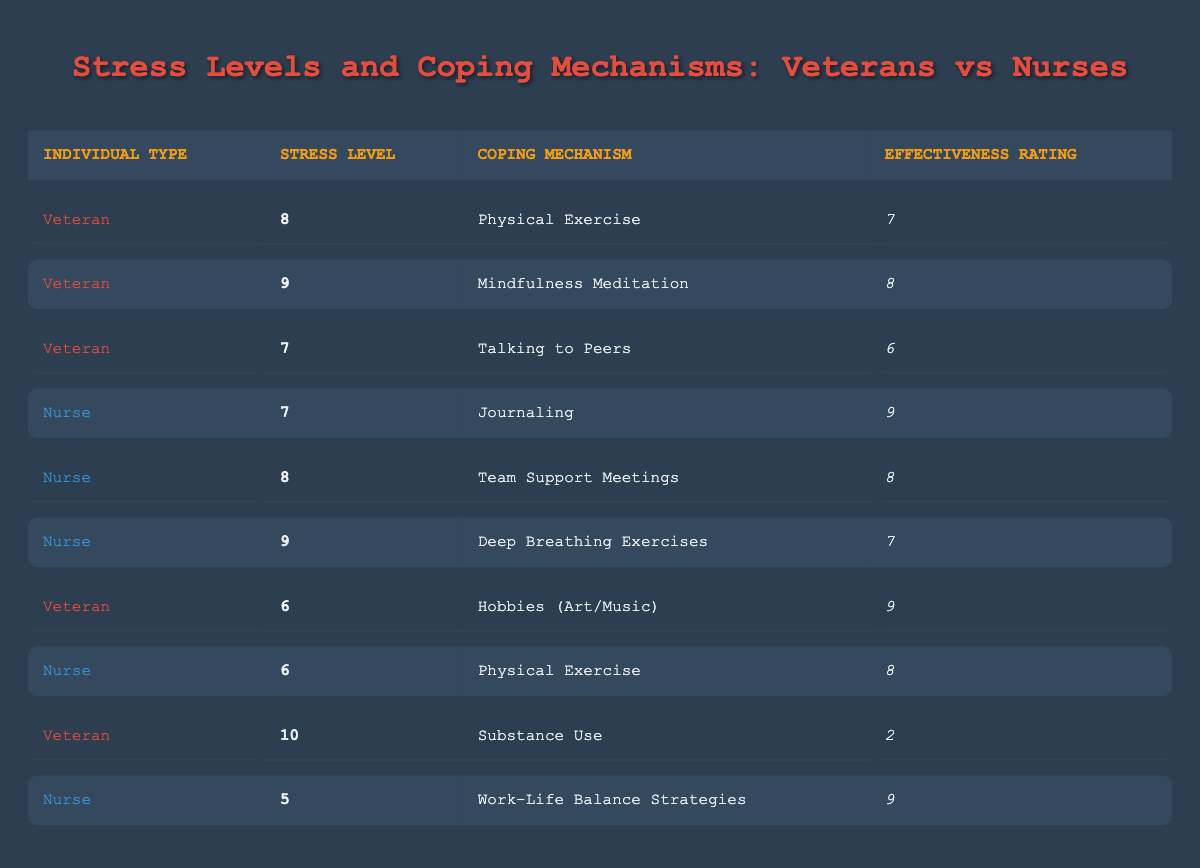What is the stress level of the veteran using "Mindfulness Meditation"? The table shows that the stress level of the veteran using "Mindfulness Meditation" is listed in the second row, where it specifically states the stress level is 9.
Answer: 9 What coping mechanism has the highest effectiveness rating among nurses? The table indicates that "Journaling" has an effectiveness rating of 9, which is the highest among all the coping mechanisms listed under nurses.
Answer: Journaling What is the difference in stress levels between the veteran using "Hobbies (Art/Music)" and the nurse using "Work-Life Balance Strategies"? The stress level for the veteran using "Hobbies (Art/Music)" is 6, while the stress level for the nurse using "Work-Life Balance Strategies" is 5. The difference is 6 - 5 = 1.
Answer: 1 Does any veteran have an effectiveness rating lower than 4? Referring to the table, the veteran using "Substance Use" has an effectiveness rating of 2, which is lower than 4. Therefore, the answer is yes.
Answer: Yes What is the average effectiveness rating for all coping mechanisms used by veterans? The effectiveness ratings for veterans are: 7, 8, 6, 9, and 2. To find the average, sum these values (7 + 8 + 6 + 9 + 2) = 32, and divide by 5 (number of entries) gives us 32 / 5 = 6.4.
Answer: 6.4 How many coping mechanisms have effectiveness ratings of 8 or higher? The coping mechanisms with effectiveness ratings of 8 or higher are: "Physical Exercise" (Veteran), "Mindfulness Meditation" (Veteran), "Journaling" (Nurse), and "Work-Life Balance Strategies" (Nurse). In total, there are 4 coping mechanisms that fit this criteria.
Answer: 4 Is "Team Support Meetings" considered a coping mechanism with a stress level of 8 and effectiveness rating of 8? Reviewing the table, "Team Support Meetings" indeed has a stress level of 8 and an effectiveness rating of 8. Therefore, the statement is true.
Answer: Yes Which individual type has the highest stress level listed in the table? The highest stress level in the table is 10, which corresponds to a veteran who uses "Substance Use." Hence, the individual type with the highest stress level is the veteran.
Answer: Veteran What percentage of the listed coping mechanisms for nurses have effectiveness ratings of 7 or above? The effectiveness ratings for nurses are: 9 (Journaling), 8 (Team Support Meetings), 7 (Deep Breathing Exercises), 8 (Physical Exercise), and 9 (Work-Life Balance Strategies). Out of 5 coping mechanisms, 5 have ratings of 7 or above, giving a percentage of (5/5) * 100 = 100%.
Answer: 100% 